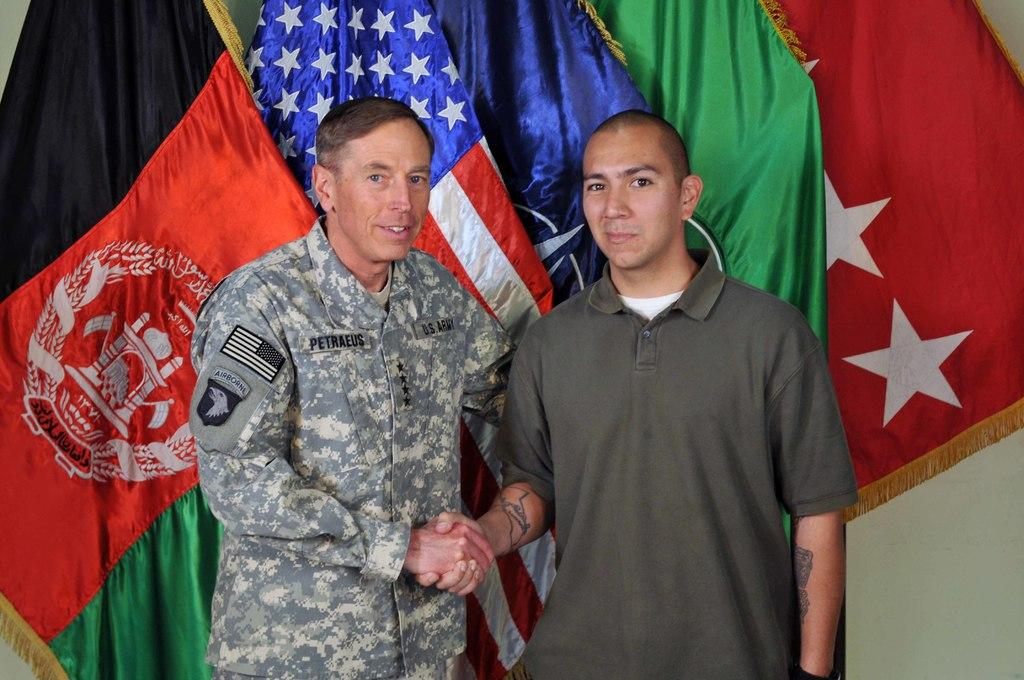<image>
Summarize the visual content of the image. Former CIA Director Petraeus shakes hands with a fan. 